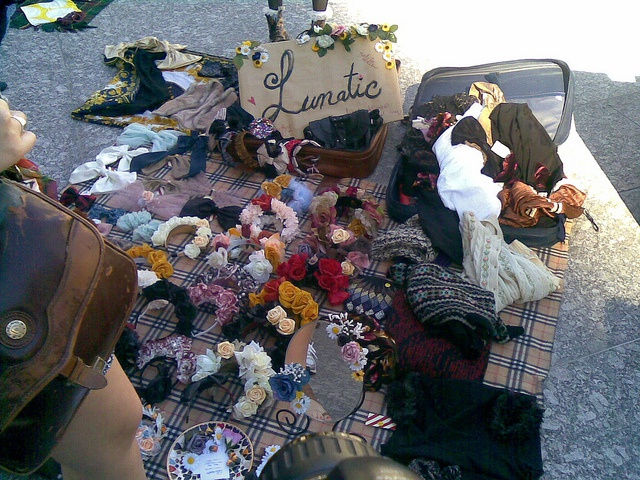Describe the objects in this image and their specific colors. I can see suitcase in navy, black, gray, white, and darkgray tones, handbag in navy, black, and gray tones, suitcase in navy, black, maroon, and gray tones, bowl in navy, lightblue, darkgray, and gray tones, and suitcase in navy, black, maroon, and gray tones in this image. 